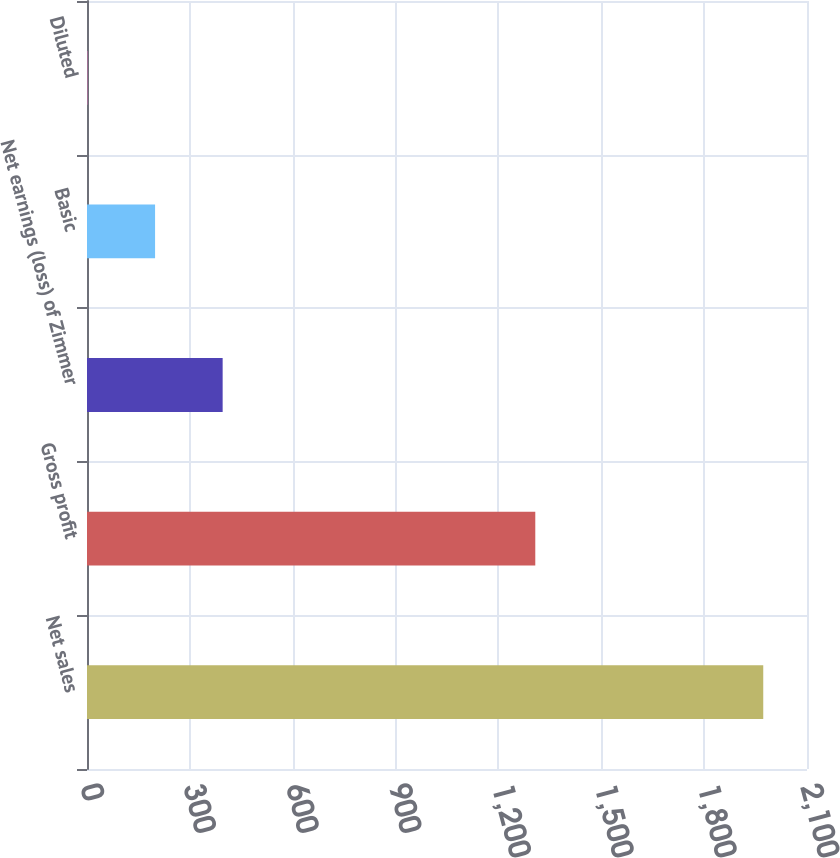<chart> <loc_0><loc_0><loc_500><loc_500><bar_chart><fcel>Net sales<fcel>Gross profit<fcel>Net earnings (loss) of Zimmer<fcel>Basic<fcel>Diluted<nl><fcel>1972.4<fcel>1307.5<fcel>395.65<fcel>198.56<fcel>1.47<nl></chart> 